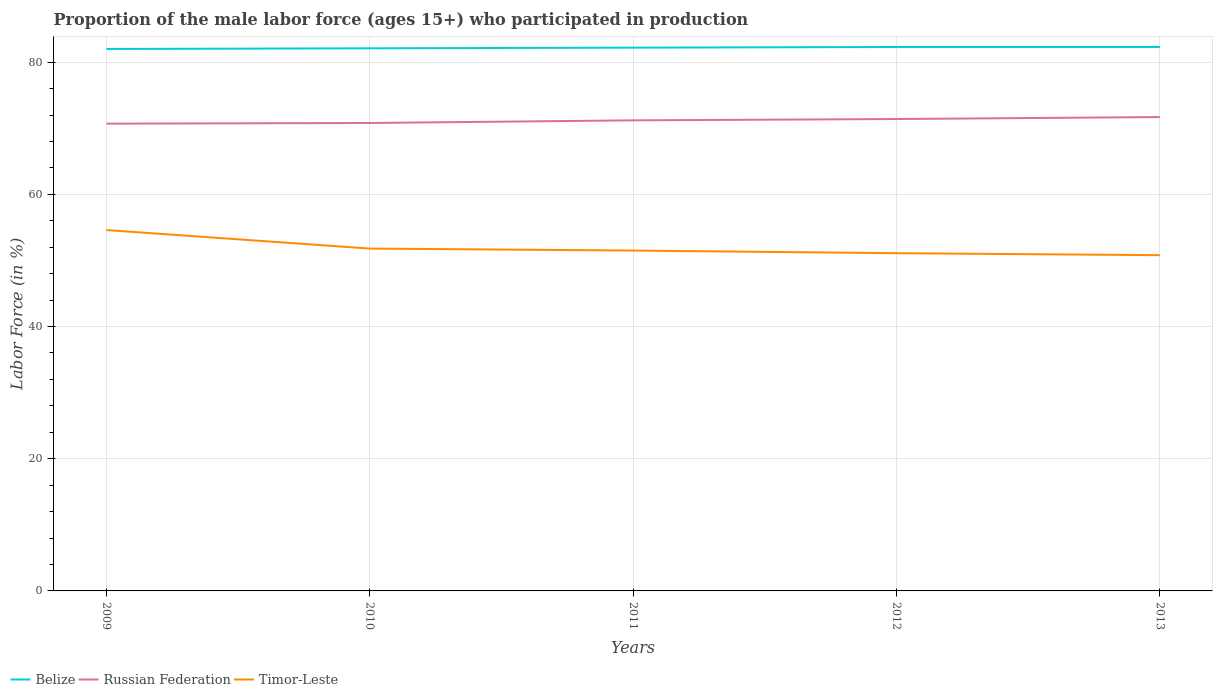Does the line corresponding to Timor-Leste intersect with the line corresponding to Russian Federation?
Offer a terse response. No. Is the number of lines equal to the number of legend labels?
Ensure brevity in your answer.  Yes. Across all years, what is the maximum proportion of the male labor force who participated in production in Belize?
Make the answer very short. 82. What is the total proportion of the male labor force who participated in production in Timor-Leste in the graph?
Ensure brevity in your answer.  3.8. What is the difference between the highest and the second highest proportion of the male labor force who participated in production in Russian Federation?
Your answer should be very brief. 1. What is the difference between the highest and the lowest proportion of the male labor force who participated in production in Russian Federation?
Give a very brief answer. 3. Is the proportion of the male labor force who participated in production in Russian Federation strictly greater than the proportion of the male labor force who participated in production in Belize over the years?
Your answer should be very brief. Yes. How many lines are there?
Your answer should be very brief. 3. What is the difference between two consecutive major ticks on the Y-axis?
Your response must be concise. 20. Are the values on the major ticks of Y-axis written in scientific E-notation?
Keep it short and to the point. No. Where does the legend appear in the graph?
Your answer should be very brief. Bottom left. How many legend labels are there?
Ensure brevity in your answer.  3. How are the legend labels stacked?
Ensure brevity in your answer.  Horizontal. What is the title of the graph?
Keep it short and to the point. Proportion of the male labor force (ages 15+) who participated in production. Does "Timor-Leste" appear as one of the legend labels in the graph?
Your response must be concise. Yes. What is the label or title of the Y-axis?
Ensure brevity in your answer.  Labor Force (in %). What is the Labor Force (in %) of Belize in 2009?
Your answer should be very brief. 82. What is the Labor Force (in %) in Russian Federation in 2009?
Offer a very short reply. 70.7. What is the Labor Force (in %) of Timor-Leste in 2009?
Your answer should be very brief. 54.6. What is the Labor Force (in %) of Belize in 2010?
Give a very brief answer. 82.1. What is the Labor Force (in %) in Russian Federation in 2010?
Ensure brevity in your answer.  70.8. What is the Labor Force (in %) of Timor-Leste in 2010?
Keep it short and to the point. 51.8. What is the Labor Force (in %) in Belize in 2011?
Make the answer very short. 82.2. What is the Labor Force (in %) in Russian Federation in 2011?
Your answer should be very brief. 71.2. What is the Labor Force (in %) of Timor-Leste in 2011?
Provide a short and direct response. 51.5. What is the Labor Force (in %) in Belize in 2012?
Make the answer very short. 82.3. What is the Labor Force (in %) of Russian Federation in 2012?
Provide a short and direct response. 71.4. What is the Labor Force (in %) in Timor-Leste in 2012?
Keep it short and to the point. 51.1. What is the Labor Force (in %) of Belize in 2013?
Give a very brief answer. 82.3. What is the Labor Force (in %) in Russian Federation in 2013?
Keep it short and to the point. 71.7. What is the Labor Force (in %) in Timor-Leste in 2013?
Make the answer very short. 50.8. Across all years, what is the maximum Labor Force (in %) of Belize?
Keep it short and to the point. 82.3. Across all years, what is the maximum Labor Force (in %) of Russian Federation?
Give a very brief answer. 71.7. Across all years, what is the maximum Labor Force (in %) of Timor-Leste?
Give a very brief answer. 54.6. Across all years, what is the minimum Labor Force (in %) in Russian Federation?
Provide a succinct answer. 70.7. Across all years, what is the minimum Labor Force (in %) in Timor-Leste?
Your response must be concise. 50.8. What is the total Labor Force (in %) of Belize in the graph?
Make the answer very short. 410.9. What is the total Labor Force (in %) in Russian Federation in the graph?
Your response must be concise. 355.8. What is the total Labor Force (in %) in Timor-Leste in the graph?
Make the answer very short. 259.8. What is the difference between the Labor Force (in %) of Belize in 2009 and that in 2010?
Offer a very short reply. -0.1. What is the difference between the Labor Force (in %) in Russian Federation in 2009 and that in 2010?
Make the answer very short. -0.1. What is the difference between the Labor Force (in %) in Belize in 2009 and that in 2011?
Offer a terse response. -0.2. What is the difference between the Labor Force (in %) in Russian Federation in 2009 and that in 2011?
Make the answer very short. -0.5. What is the difference between the Labor Force (in %) in Timor-Leste in 2009 and that in 2011?
Provide a succinct answer. 3.1. What is the difference between the Labor Force (in %) of Russian Federation in 2009 and that in 2012?
Provide a short and direct response. -0.7. What is the difference between the Labor Force (in %) in Belize in 2009 and that in 2013?
Offer a very short reply. -0.3. What is the difference between the Labor Force (in %) in Russian Federation in 2009 and that in 2013?
Your answer should be compact. -1. What is the difference between the Labor Force (in %) of Timor-Leste in 2009 and that in 2013?
Offer a terse response. 3.8. What is the difference between the Labor Force (in %) of Belize in 2010 and that in 2011?
Provide a succinct answer. -0.1. What is the difference between the Labor Force (in %) in Russian Federation in 2010 and that in 2011?
Your response must be concise. -0.4. What is the difference between the Labor Force (in %) in Belize in 2010 and that in 2012?
Offer a terse response. -0.2. What is the difference between the Labor Force (in %) of Russian Federation in 2010 and that in 2012?
Your response must be concise. -0.6. What is the difference between the Labor Force (in %) in Timor-Leste in 2010 and that in 2012?
Your answer should be compact. 0.7. What is the difference between the Labor Force (in %) in Russian Federation in 2011 and that in 2012?
Your answer should be very brief. -0.2. What is the difference between the Labor Force (in %) in Timor-Leste in 2011 and that in 2012?
Your response must be concise. 0.4. What is the difference between the Labor Force (in %) of Russian Federation in 2011 and that in 2013?
Give a very brief answer. -0.5. What is the difference between the Labor Force (in %) of Russian Federation in 2012 and that in 2013?
Provide a succinct answer. -0.3. What is the difference between the Labor Force (in %) of Belize in 2009 and the Labor Force (in %) of Russian Federation in 2010?
Your response must be concise. 11.2. What is the difference between the Labor Force (in %) in Belize in 2009 and the Labor Force (in %) in Timor-Leste in 2010?
Keep it short and to the point. 30.2. What is the difference between the Labor Force (in %) of Belize in 2009 and the Labor Force (in %) of Timor-Leste in 2011?
Provide a short and direct response. 30.5. What is the difference between the Labor Force (in %) of Russian Federation in 2009 and the Labor Force (in %) of Timor-Leste in 2011?
Keep it short and to the point. 19.2. What is the difference between the Labor Force (in %) of Belize in 2009 and the Labor Force (in %) of Russian Federation in 2012?
Your response must be concise. 10.6. What is the difference between the Labor Force (in %) of Belize in 2009 and the Labor Force (in %) of Timor-Leste in 2012?
Give a very brief answer. 30.9. What is the difference between the Labor Force (in %) in Russian Federation in 2009 and the Labor Force (in %) in Timor-Leste in 2012?
Offer a terse response. 19.6. What is the difference between the Labor Force (in %) of Belize in 2009 and the Labor Force (in %) of Russian Federation in 2013?
Give a very brief answer. 10.3. What is the difference between the Labor Force (in %) of Belize in 2009 and the Labor Force (in %) of Timor-Leste in 2013?
Your answer should be compact. 31.2. What is the difference between the Labor Force (in %) of Russian Federation in 2009 and the Labor Force (in %) of Timor-Leste in 2013?
Your answer should be compact. 19.9. What is the difference between the Labor Force (in %) in Belize in 2010 and the Labor Force (in %) in Timor-Leste in 2011?
Give a very brief answer. 30.6. What is the difference between the Labor Force (in %) of Russian Federation in 2010 and the Labor Force (in %) of Timor-Leste in 2011?
Ensure brevity in your answer.  19.3. What is the difference between the Labor Force (in %) of Belize in 2010 and the Labor Force (in %) of Timor-Leste in 2013?
Provide a succinct answer. 31.3. What is the difference between the Labor Force (in %) in Russian Federation in 2010 and the Labor Force (in %) in Timor-Leste in 2013?
Your answer should be very brief. 20. What is the difference between the Labor Force (in %) in Belize in 2011 and the Labor Force (in %) in Timor-Leste in 2012?
Provide a short and direct response. 31.1. What is the difference between the Labor Force (in %) of Russian Federation in 2011 and the Labor Force (in %) of Timor-Leste in 2012?
Provide a short and direct response. 20.1. What is the difference between the Labor Force (in %) of Belize in 2011 and the Labor Force (in %) of Timor-Leste in 2013?
Give a very brief answer. 31.4. What is the difference between the Labor Force (in %) of Russian Federation in 2011 and the Labor Force (in %) of Timor-Leste in 2013?
Offer a terse response. 20.4. What is the difference between the Labor Force (in %) of Belize in 2012 and the Labor Force (in %) of Russian Federation in 2013?
Give a very brief answer. 10.6. What is the difference between the Labor Force (in %) in Belize in 2012 and the Labor Force (in %) in Timor-Leste in 2013?
Provide a short and direct response. 31.5. What is the difference between the Labor Force (in %) of Russian Federation in 2012 and the Labor Force (in %) of Timor-Leste in 2013?
Provide a succinct answer. 20.6. What is the average Labor Force (in %) of Belize per year?
Make the answer very short. 82.18. What is the average Labor Force (in %) in Russian Federation per year?
Keep it short and to the point. 71.16. What is the average Labor Force (in %) of Timor-Leste per year?
Provide a succinct answer. 51.96. In the year 2009, what is the difference between the Labor Force (in %) in Belize and Labor Force (in %) in Timor-Leste?
Give a very brief answer. 27.4. In the year 2009, what is the difference between the Labor Force (in %) in Russian Federation and Labor Force (in %) in Timor-Leste?
Provide a succinct answer. 16.1. In the year 2010, what is the difference between the Labor Force (in %) of Belize and Labor Force (in %) of Russian Federation?
Keep it short and to the point. 11.3. In the year 2010, what is the difference between the Labor Force (in %) in Belize and Labor Force (in %) in Timor-Leste?
Your answer should be compact. 30.3. In the year 2010, what is the difference between the Labor Force (in %) in Russian Federation and Labor Force (in %) in Timor-Leste?
Your answer should be very brief. 19. In the year 2011, what is the difference between the Labor Force (in %) of Belize and Labor Force (in %) of Timor-Leste?
Give a very brief answer. 30.7. In the year 2012, what is the difference between the Labor Force (in %) of Belize and Labor Force (in %) of Russian Federation?
Provide a succinct answer. 10.9. In the year 2012, what is the difference between the Labor Force (in %) in Belize and Labor Force (in %) in Timor-Leste?
Your response must be concise. 31.2. In the year 2012, what is the difference between the Labor Force (in %) in Russian Federation and Labor Force (in %) in Timor-Leste?
Make the answer very short. 20.3. In the year 2013, what is the difference between the Labor Force (in %) of Belize and Labor Force (in %) of Timor-Leste?
Provide a short and direct response. 31.5. In the year 2013, what is the difference between the Labor Force (in %) in Russian Federation and Labor Force (in %) in Timor-Leste?
Give a very brief answer. 20.9. What is the ratio of the Labor Force (in %) in Belize in 2009 to that in 2010?
Ensure brevity in your answer.  1. What is the ratio of the Labor Force (in %) in Russian Federation in 2009 to that in 2010?
Give a very brief answer. 1. What is the ratio of the Labor Force (in %) in Timor-Leste in 2009 to that in 2010?
Offer a terse response. 1.05. What is the ratio of the Labor Force (in %) of Russian Federation in 2009 to that in 2011?
Keep it short and to the point. 0.99. What is the ratio of the Labor Force (in %) of Timor-Leste in 2009 to that in 2011?
Your response must be concise. 1.06. What is the ratio of the Labor Force (in %) in Russian Federation in 2009 to that in 2012?
Offer a very short reply. 0.99. What is the ratio of the Labor Force (in %) in Timor-Leste in 2009 to that in 2012?
Offer a very short reply. 1.07. What is the ratio of the Labor Force (in %) of Russian Federation in 2009 to that in 2013?
Ensure brevity in your answer.  0.99. What is the ratio of the Labor Force (in %) of Timor-Leste in 2009 to that in 2013?
Your response must be concise. 1.07. What is the ratio of the Labor Force (in %) of Belize in 2010 to that in 2011?
Offer a very short reply. 1. What is the ratio of the Labor Force (in %) in Russian Federation in 2010 to that in 2011?
Your answer should be very brief. 0.99. What is the ratio of the Labor Force (in %) of Timor-Leste in 2010 to that in 2011?
Offer a very short reply. 1.01. What is the ratio of the Labor Force (in %) in Russian Federation in 2010 to that in 2012?
Your answer should be compact. 0.99. What is the ratio of the Labor Force (in %) in Timor-Leste in 2010 to that in 2012?
Offer a terse response. 1.01. What is the ratio of the Labor Force (in %) in Belize in 2010 to that in 2013?
Provide a succinct answer. 1. What is the ratio of the Labor Force (in %) in Russian Federation in 2010 to that in 2013?
Offer a terse response. 0.99. What is the ratio of the Labor Force (in %) of Timor-Leste in 2010 to that in 2013?
Give a very brief answer. 1.02. What is the ratio of the Labor Force (in %) of Timor-Leste in 2011 to that in 2013?
Make the answer very short. 1.01. What is the ratio of the Labor Force (in %) in Belize in 2012 to that in 2013?
Ensure brevity in your answer.  1. What is the ratio of the Labor Force (in %) of Russian Federation in 2012 to that in 2013?
Make the answer very short. 1. What is the ratio of the Labor Force (in %) in Timor-Leste in 2012 to that in 2013?
Make the answer very short. 1.01. What is the difference between the highest and the lowest Labor Force (in %) in Russian Federation?
Your answer should be compact. 1. 